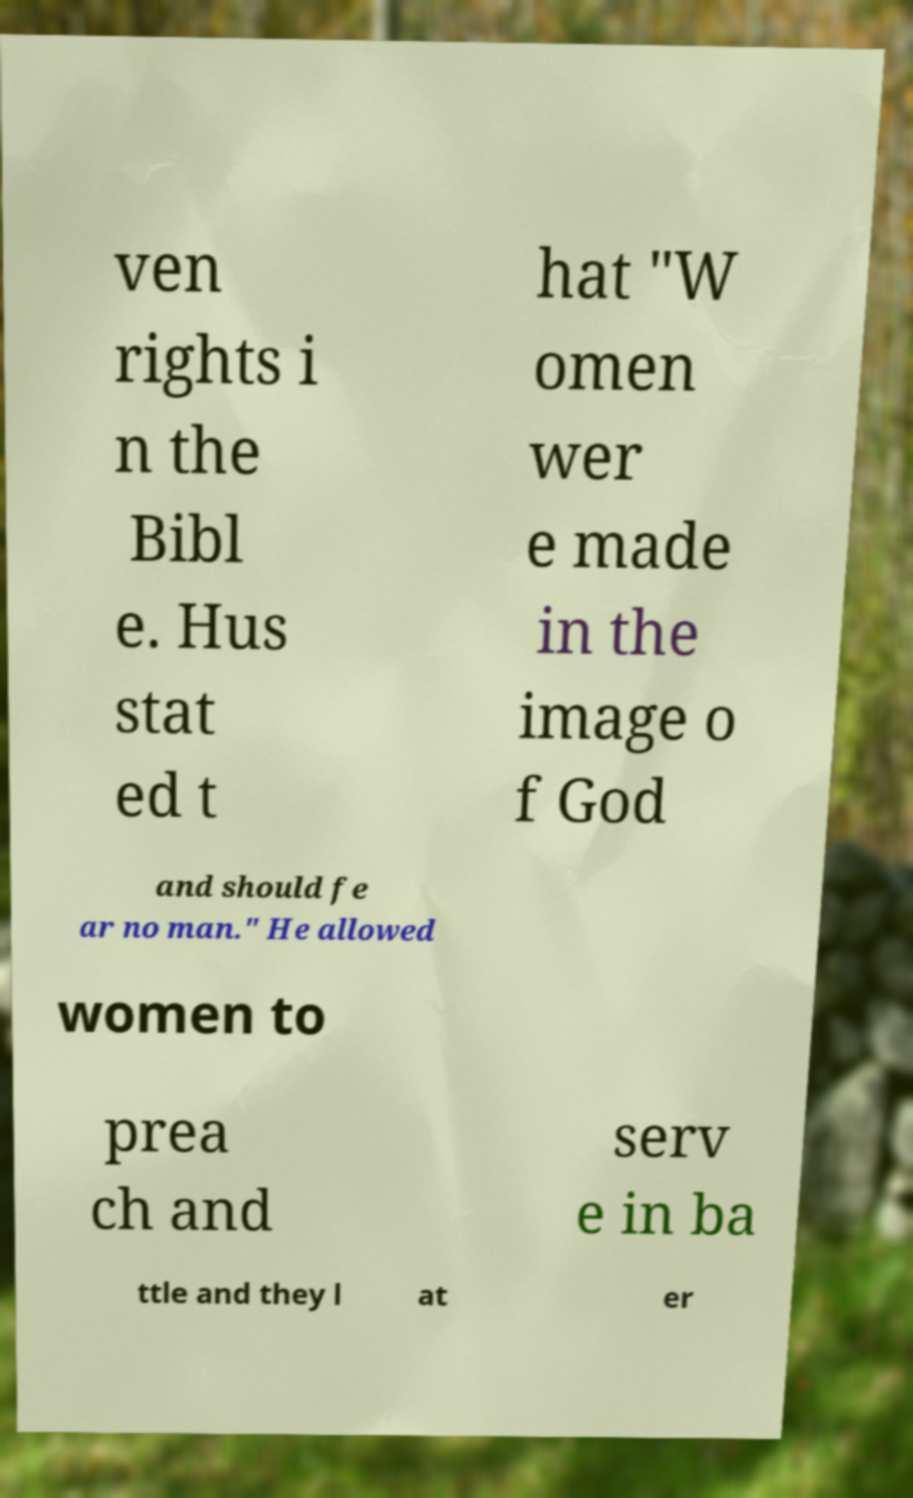For documentation purposes, I need the text within this image transcribed. Could you provide that? ven rights i n the Bibl e. Hus stat ed t hat "W omen wer e made in the image o f God and should fe ar no man." He allowed women to prea ch and serv e in ba ttle and they l at er 